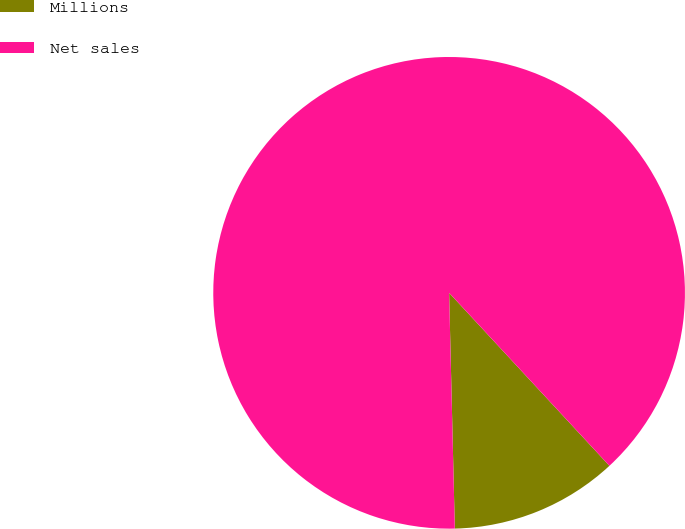Convert chart to OTSL. <chart><loc_0><loc_0><loc_500><loc_500><pie_chart><fcel>Millions<fcel>Net sales<nl><fcel>11.51%<fcel>88.49%<nl></chart> 